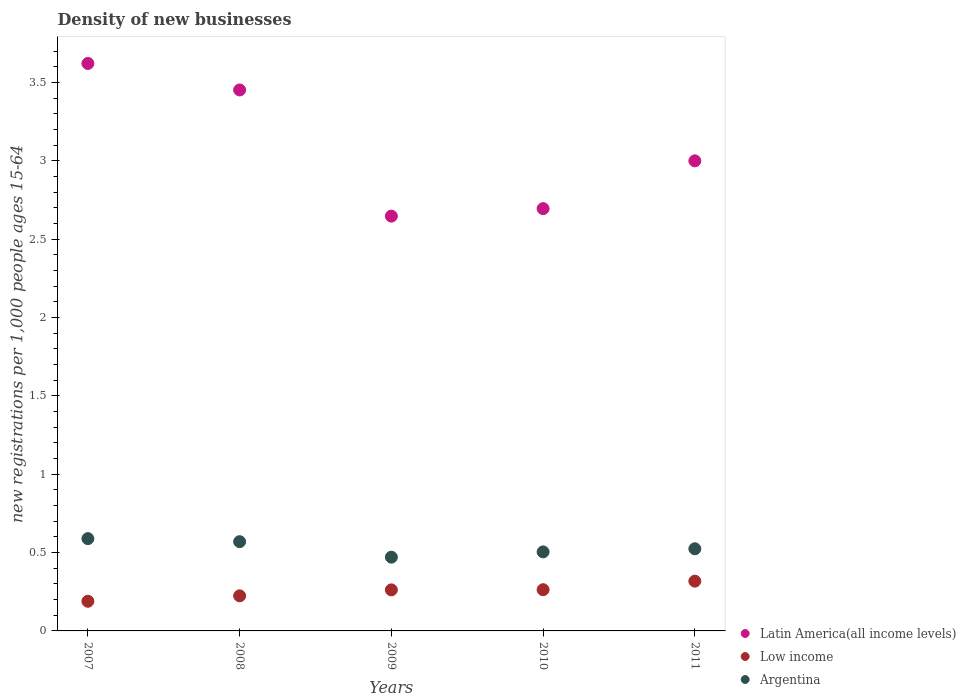Is the number of dotlines equal to the number of legend labels?
Offer a very short reply. Yes. What is the number of new registrations in Low income in 2011?
Your response must be concise. 0.32. Across all years, what is the maximum number of new registrations in Low income?
Offer a terse response. 0.32. Across all years, what is the minimum number of new registrations in Argentina?
Provide a succinct answer. 0.47. In which year was the number of new registrations in Argentina minimum?
Provide a short and direct response. 2009. What is the total number of new registrations in Argentina in the graph?
Offer a terse response. 2.66. What is the difference between the number of new registrations in Low income in 2007 and that in 2010?
Your response must be concise. -0.07. What is the difference between the number of new registrations in Argentina in 2007 and the number of new registrations in Low income in 2009?
Your response must be concise. 0.33. What is the average number of new registrations in Argentina per year?
Offer a very short reply. 0.53. In the year 2008, what is the difference between the number of new registrations in Low income and number of new registrations in Latin America(all income levels)?
Your answer should be very brief. -3.23. What is the ratio of the number of new registrations in Argentina in 2007 to that in 2010?
Your answer should be very brief. 1.17. What is the difference between the highest and the second highest number of new registrations in Argentina?
Your response must be concise. 0.02. What is the difference between the highest and the lowest number of new registrations in Latin America(all income levels)?
Your answer should be compact. 0.97. Does the number of new registrations in Low income monotonically increase over the years?
Provide a succinct answer. Yes. Is the number of new registrations in Low income strictly less than the number of new registrations in Argentina over the years?
Give a very brief answer. Yes. How many dotlines are there?
Make the answer very short. 3. How many years are there in the graph?
Offer a very short reply. 5. Does the graph contain grids?
Offer a very short reply. No. What is the title of the graph?
Give a very brief answer. Density of new businesses. What is the label or title of the Y-axis?
Provide a succinct answer. New registrations per 1,0 people ages 15-64. What is the new registrations per 1,000 people ages 15-64 of Latin America(all income levels) in 2007?
Give a very brief answer. 3.62. What is the new registrations per 1,000 people ages 15-64 of Low income in 2007?
Provide a succinct answer. 0.19. What is the new registrations per 1,000 people ages 15-64 of Argentina in 2007?
Provide a short and direct response. 0.59. What is the new registrations per 1,000 people ages 15-64 in Latin America(all income levels) in 2008?
Give a very brief answer. 3.45. What is the new registrations per 1,000 people ages 15-64 in Low income in 2008?
Offer a terse response. 0.22. What is the new registrations per 1,000 people ages 15-64 in Argentina in 2008?
Provide a succinct answer. 0.57. What is the new registrations per 1,000 people ages 15-64 of Latin America(all income levels) in 2009?
Your response must be concise. 2.65. What is the new registrations per 1,000 people ages 15-64 of Low income in 2009?
Your response must be concise. 0.26. What is the new registrations per 1,000 people ages 15-64 of Argentina in 2009?
Ensure brevity in your answer.  0.47. What is the new registrations per 1,000 people ages 15-64 of Latin America(all income levels) in 2010?
Keep it short and to the point. 2.69. What is the new registrations per 1,000 people ages 15-64 in Low income in 2010?
Offer a very short reply. 0.26. What is the new registrations per 1,000 people ages 15-64 of Argentina in 2010?
Ensure brevity in your answer.  0.5. What is the new registrations per 1,000 people ages 15-64 in Latin America(all income levels) in 2011?
Give a very brief answer. 3. What is the new registrations per 1,000 people ages 15-64 in Low income in 2011?
Your response must be concise. 0.32. What is the new registrations per 1,000 people ages 15-64 of Argentina in 2011?
Your answer should be compact. 0.52. Across all years, what is the maximum new registrations per 1,000 people ages 15-64 of Latin America(all income levels)?
Give a very brief answer. 3.62. Across all years, what is the maximum new registrations per 1,000 people ages 15-64 of Low income?
Your answer should be very brief. 0.32. Across all years, what is the maximum new registrations per 1,000 people ages 15-64 of Argentina?
Ensure brevity in your answer.  0.59. Across all years, what is the minimum new registrations per 1,000 people ages 15-64 of Latin America(all income levels)?
Your answer should be compact. 2.65. Across all years, what is the minimum new registrations per 1,000 people ages 15-64 in Low income?
Your answer should be very brief. 0.19. Across all years, what is the minimum new registrations per 1,000 people ages 15-64 in Argentina?
Provide a short and direct response. 0.47. What is the total new registrations per 1,000 people ages 15-64 of Latin America(all income levels) in the graph?
Offer a terse response. 15.41. What is the total new registrations per 1,000 people ages 15-64 of Low income in the graph?
Provide a succinct answer. 1.26. What is the total new registrations per 1,000 people ages 15-64 of Argentina in the graph?
Keep it short and to the point. 2.66. What is the difference between the new registrations per 1,000 people ages 15-64 of Latin America(all income levels) in 2007 and that in 2008?
Offer a terse response. 0.17. What is the difference between the new registrations per 1,000 people ages 15-64 of Low income in 2007 and that in 2008?
Your response must be concise. -0.03. What is the difference between the new registrations per 1,000 people ages 15-64 of Argentina in 2007 and that in 2008?
Your answer should be very brief. 0.02. What is the difference between the new registrations per 1,000 people ages 15-64 of Latin America(all income levels) in 2007 and that in 2009?
Offer a terse response. 0.97. What is the difference between the new registrations per 1,000 people ages 15-64 in Low income in 2007 and that in 2009?
Ensure brevity in your answer.  -0.07. What is the difference between the new registrations per 1,000 people ages 15-64 in Argentina in 2007 and that in 2009?
Give a very brief answer. 0.12. What is the difference between the new registrations per 1,000 people ages 15-64 of Latin America(all income levels) in 2007 and that in 2010?
Make the answer very short. 0.93. What is the difference between the new registrations per 1,000 people ages 15-64 in Low income in 2007 and that in 2010?
Offer a very short reply. -0.07. What is the difference between the new registrations per 1,000 people ages 15-64 of Argentina in 2007 and that in 2010?
Offer a terse response. 0.08. What is the difference between the new registrations per 1,000 people ages 15-64 in Latin America(all income levels) in 2007 and that in 2011?
Provide a succinct answer. 0.62. What is the difference between the new registrations per 1,000 people ages 15-64 in Low income in 2007 and that in 2011?
Your answer should be compact. -0.13. What is the difference between the new registrations per 1,000 people ages 15-64 in Argentina in 2007 and that in 2011?
Give a very brief answer. 0.06. What is the difference between the new registrations per 1,000 people ages 15-64 in Latin America(all income levels) in 2008 and that in 2009?
Your answer should be compact. 0.81. What is the difference between the new registrations per 1,000 people ages 15-64 of Low income in 2008 and that in 2009?
Ensure brevity in your answer.  -0.04. What is the difference between the new registrations per 1,000 people ages 15-64 in Argentina in 2008 and that in 2009?
Your answer should be compact. 0.1. What is the difference between the new registrations per 1,000 people ages 15-64 in Latin America(all income levels) in 2008 and that in 2010?
Your answer should be compact. 0.76. What is the difference between the new registrations per 1,000 people ages 15-64 in Low income in 2008 and that in 2010?
Keep it short and to the point. -0.04. What is the difference between the new registrations per 1,000 people ages 15-64 of Argentina in 2008 and that in 2010?
Provide a short and direct response. 0.07. What is the difference between the new registrations per 1,000 people ages 15-64 in Latin America(all income levels) in 2008 and that in 2011?
Give a very brief answer. 0.45. What is the difference between the new registrations per 1,000 people ages 15-64 of Low income in 2008 and that in 2011?
Give a very brief answer. -0.09. What is the difference between the new registrations per 1,000 people ages 15-64 in Argentina in 2008 and that in 2011?
Provide a succinct answer. 0.05. What is the difference between the new registrations per 1,000 people ages 15-64 of Latin America(all income levels) in 2009 and that in 2010?
Your answer should be very brief. -0.05. What is the difference between the new registrations per 1,000 people ages 15-64 of Low income in 2009 and that in 2010?
Your answer should be very brief. -0. What is the difference between the new registrations per 1,000 people ages 15-64 of Argentina in 2009 and that in 2010?
Ensure brevity in your answer.  -0.03. What is the difference between the new registrations per 1,000 people ages 15-64 in Latin America(all income levels) in 2009 and that in 2011?
Your response must be concise. -0.35. What is the difference between the new registrations per 1,000 people ages 15-64 of Low income in 2009 and that in 2011?
Make the answer very short. -0.06. What is the difference between the new registrations per 1,000 people ages 15-64 in Argentina in 2009 and that in 2011?
Provide a succinct answer. -0.05. What is the difference between the new registrations per 1,000 people ages 15-64 of Latin America(all income levels) in 2010 and that in 2011?
Keep it short and to the point. -0.3. What is the difference between the new registrations per 1,000 people ages 15-64 of Low income in 2010 and that in 2011?
Offer a terse response. -0.05. What is the difference between the new registrations per 1,000 people ages 15-64 in Argentina in 2010 and that in 2011?
Your answer should be very brief. -0.02. What is the difference between the new registrations per 1,000 people ages 15-64 in Latin America(all income levels) in 2007 and the new registrations per 1,000 people ages 15-64 in Low income in 2008?
Give a very brief answer. 3.4. What is the difference between the new registrations per 1,000 people ages 15-64 in Latin America(all income levels) in 2007 and the new registrations per 1,000 people ages 15-64 in Argentina in 2008?
Ensure brevity in your answer.  3.05. What is the difference between the new registrations per 1,000 people ages 15-64 of Low income in 2007 and the new registrations per 1,000 people ages 15-64 of Argentina in 2008?
Make the answer very short. -0.38. What is the difference between the new registrations per 1,000 people ages 15-64 of Latin America(all income levels) in 2007 and the new registrations per 1,000 people ages 15-64 of Low income in 2009?
Offer a very short reply. 3.36. What is the difference between the new registrations per 1,000 people ages 15-64 of Latin America(all income levels) in 2007 and the new registrations per 1,000 people ages 15-64 of Argentina in 2009?
Offer a terse response. 3.15. What is the difference between the new registrations per 1,000 people ages 15-64 in Low income in 2007 and the new registrations per 1,000 people ages 15-64 in Argentina in 2009?
Your answer should be compact. -0.28. What is the difference between the new registrations per 1,000 people ages 15-64 of Latin America(all income levels) in 2007 and the new registrations per 1,000 people ages 15-64 of Low income in 2010?
Your response must be concise. 3.36. What is the difference between the new registrations per 1,000 people ages 15-64 of Latin America(all income levels) in 2007 and the new registrations per 1,000 people ages 15-64 of Argentina in 2010?
Offer a terse response. 3.12. What is the difference between the new registrations per 1,000 people ages 15-64 in Low income in 2007 and the new registrations per 1,000 people ages 15-64 in Argentina in 2010?
Keep it short and to the point. -0.32. What is the difference between the new registrations per 1,000 people ages 15-64 of Latin America(all income levels) in 2007 and the new registrations per 1,000 people ages 15-64 of Low income in 2011?
Ensure brevity in your answer.  3.3. What is the difference between the new registrations per 1,000 people ages 15-64 of Latin America(all income levels) in 2007 and the new registrations per 1,000 people ages 15-64 of Argentina in 2011?
Offer a terse response. 3.1. What is the difference between the new registrations per 1,000 people ages 15-64 in Low income in 2007 and the new registrations per 1,000 people ages 15-64 in Argentina in 2011?
Give a very brief answer. -0.34. What is the difference between the new registrations per 1,000 people ages 15-64 in Latin America(all income levels) in 2008 and the new registrations per 1,000 people ages 15-64 in Low income in 2009?
Provide a short and direct response. 3.19. What is the difference between the new registrations per 1,000 people ages 15-64 of Latin America(all income levels) in 2008 and the new registrations per 1,000 people ages 15-64 of Argentina in 2009?
Your response must be concise. 2.98. What is the difference between the new registrations per 1,000 people ages 15-64 in Low income in 2008 and the new registrations per 1,000 people ages 15-64 in Argentina in 2009?
Keep it short and to the point. -0.25. What is the difference between the new registrations per 1,000 people ages 15-64 in Latin America(all income levels) in 2008 and the new registrations per 1,000 people ages 15-64 in Low income in 2010?
Keep it short and to the point. 3.19. What is the difference between the new registrations per 1,000 people ages 15-64 in Latin America(all income levels) in 2008 and the new registrations per 1,000 people ages 15-64 in Argentina in 2010?
Provide a short and direct response. 2.95. What is the difference between the new registrations per 1,000 people ages 15-64 of Low income in 2008 and the new registrations per 1,000 people ages 15-64 of Argentina in 2010?
Your response must be concise. -0.28. What is the difference between the new registrations per 1,000 people ages 15-64 of Latin America(all income levels) in 2008 and the new registrations per 1,000 people ages 15-64 of Low income in 2011?
Your response must be concise. 3.13. What is the difference between the new registrations per 1,000 people ages 15-64 of Latin America(all income levels) in 2008 and the new registrations per 1,000 people ages 15-64 of Argentina in 2011?
Your answer should be very brief. 2.93. What is the difference between the new registrations per 1,000 people ages 15-64 in Low income in 2008 and the new registrations per 1,000 people ages 15-64 in Argentina in 2011?
Ensure brevity in your answer.  -0.3. What is the difference between the new registrations per 1,000 people ages 15-64 of Latin America(all income levels) in 2009 and the new registrations per 1,000 people ages 15-64 of Low income in 2010?
Provide a short and direct response. 2.38. What is the difference between the new registrations per 1,000 people ages 15-64 in Latin America(all income levels) in 2009 and the new registrations per 1,000 people ages 15-64 in Argentina in 2010?
Provide a short and direct response. 2.14. What is the difference between the new registrations per 1,000 people ages 15-64 in Low income in 2009 and the new registrations per 1,000 people ages 15-64 in Argentina in 2010?
Offer a terse response. -0.24. What is the difference between the new registrations per 1,000 people ages 15-64 in Latin America(all income levels) in 2009 and the new registrations per 1,000 people ages 15-64 in Low income in 2011?
Provide a short and direct response. 2.33. What is the difference between the new registrations per 1,000 people ages 15-64 in Latin America(all income levels) in 2009 and the new registrations per 1,000 people ages 15-64 in Argentina in 2011?
Your answer should be compact. 2.12. What is the difference between the new registrations per 1,000 people ages 15-64 in Low income in 2009 and the new registrations per 1,000 people ages 15-64 in Argentina in 2011?
Provide a short and direct response. -0.26. What is the difference between the new registrations per 1,000 people ages 15-64 of Latin America(all income levels) in 2010 and the new registrations per 1,000 people ages 15-64 of Low income in 2011?
Offer a terse response. 2.38. What is the difference between the new registrations per 1,000 people ages 15-64 of Latin America(all income levels) in 2010 and the new registrations per 1,000 people ages 15-64 of Argentina in 2011?
Provide a short and direct response. 2.17. What is the difference between the new registrations per 1,000 people ages 15-64 of Low income in 2010 and the new registrations per 1,000 people ages 15-64 of Argentina in 2011?
Your answer should be compact. -0.26. What is the average new registrations per 1,000 people ages 15-64 in Latin America(all income levels) per year?
Offer a very short reply. 3.08. What is the average new registrations per 1,000 people ages 15-64 in Low income per year?
Provide a succinct answer. 0.25. What is the average new registrations per 1,000 people ages 15-64 in Argentina per year?
Offer a terse response. 0.53. In the year 2007, what is the difference between the new registrations per 1,000 people ages 15-64 of Latin America(all income levels) and new registrations per 1,000 people ages 15-64 of Low income?
Ensure brevity in your answer.  3.43. In the year 2007, what is the difference between the new registrations per 1,000 people ages 15-64 in Latin America(all income levels) and new registrations per 1,000 people ages 15-64 in Argentina?
Your answer should be very brief. 3.03. In the year 2007, what is the difference between the new registrations per 1,000 people ages 15-64 of Low income and new registrations per 1,000 people ages 15-64 of Argentina?
Give a very brief answer. -0.4. In the year 2008, what is the difference between the new registrations per 1,000 people ages 15-64 of Latin America(all income levels) and new registrations per 1,000 people ages 15-64 of Low income?
Offer a very short reply. 3.23. In the year 2008, what is the difference between the new registrations per 1,000 people ages 15-64 in Latin America(all income levels) and new registrations per 1,000 people ages 15-64 in Argentina?
Provide a succinct answer. 2.88. In the year 2008, what is the difference between the new registrations per 1,000 people ages 15-64 of Low income and new registrations per 1,000 people ages 15-64 of Argentina?
Give a very brief answer. -0.35. In the year 2009, what is the difference between the new registrations per 1,000 people ages 15-64 of Latin America(all income levels) and new registrations per 1,000 people ages 15-64 of Low income?
Ensure brevity in your answer.  2.38. In the year 2009, what is the difference between the new registrations per 1,000 people ages 15-64 in Latin America(all income levels) and new registrations per 1,000 people ages 15-64 in Argentina?
Provide a succinct answer. 2.18. In the year 2009, what is the difference between the new registrations per 1,000 people ages 15-64 of Low income and new registrations per 1,000 people ages 15-64 of Argentina?
Provide a succinct answer. -0.21. In the year 2010, what is the difference between the new registrations per 1,000 people ages 15-64 of Latin America(all income levels) and new registrations per 1,000 people ages 15-64 of Low income?
Your answer should be compact. 2.43. In the year 2010, what is the difference between the new registrations per 1,000 people ages 15-64 of Latin America(all income levels) and new registrations per 1,000 people ages 15-64 of Argentina?
Your response must be concise. 2.19. In the year 2010, what is the difference between the new registrations per 1,000 people ages 15-64 in Low income and new registrations per 1,000 people ages 15-64 in Argentina?
Offer a very short reply. -0.24. In the year 2011, what is the difference between the new registrations per 1,000 people ages 15-64 in Latin America(all income levels) and new registrations per 1,000 people ages 15-64 in Low income?
Keep it short and to the point. 2.68. In the year 2011, what is the difference between the new registrations per 1,000 people ages 15-64 of Latin America(all income levels) and new registrations per 1,000 people ages 15-64 of Argentina?
Your response must be concise. 2.48. In the year 2011, what is the difference between the new registrations per 1,000 people ages 15-64 in Low income and new registrations per 1,000 people ages 15-64 in Argentina?
Give a very brief answer. -0.21. What is the ratio of the new registrations per 1,000 people ages 15-64 in Latin America(all income levels) in 2007 to that in 2008?
Give a very brief answer. 1.05. What is the ratio of the new registrations per 1,000 people ages 15-64 in Low income in 2007 to that in 2008?
Keep it short and to the point. 0.84. What is the ratio of the new registrations per 1,000 people ages 15-64 in Argentina in 2007 to that in 2008?
Keep it short and to the point. 1.03. What is the ratio of the new registrations per 1,000 people ages 15-64 in Latin America(all income levels) in 2007 to that in 2009?
Provide a short and direct response. 1.37. What is the ratio of the new registrations per 1,000 people ages 15-64 of Low income in 2007 to that in 2009?
Your answer should be compact. 0.72. What is the ratio of the new registrations per 1,000 people ages 15-64 of Argentina in 2007 to that in 2009?
Your answer should be compact. 1.25. What is the ratio of the new registrations per 1,000 people ages 15-64 in Latin America(all income levels) in 2007 to that in 2010?
Your answer should be very brief. 1.34. What is the ratio of the new registrations per 1,000 people ages 15-64 in Low income in 2007 to that in 2010?
Your answer should be very brief. 0.72. What is the ratio of the new registrations per 1,000 people ages 15-64 in Argentina in 2007 to that in 2010?
Provide a succinct answer. 1.17. What is the ratio of the new registrations per 1,000 people ages 15-64 of Latin America(all income levels) in 2007 to that in 2011?
Give a very brief answer. 1.21. What is the ratio of the new registrations per 1,000 people ages 15-64 in Low income in 2007 to that in 2011?
Give a very brief answer. 0.6. What is the ratio of the new registrations per 1,000 people ages 15-64 in Argentina in 2007 to that in 2011?
Your answer should be compact. 1.12. What is the ratio of the new registrations per 1,000 people ages 15-64 of Latin America(all income levels) in 2008 to that in 2009?
Keep it short and to the point. 1.3. What is the ratio of the new registrations per 1,000 people ages 15-64 in Low income in 2008 to that in 2009?
Give a very brief answer. 0.85. What is the ratio of the new registrations per 1,000 people ages 15-64 in Argentina in 2008 to that in 2009?
Your response must be concise. 1.21. What is the ratio of the new registrations per 1,000 people ages 15-64 of Latin America(all income levels) in 2008 to that in 2010?
Offer a very short reply. 1.28. What is the ratio of the new registrations per 1,000 people ages 15-64 of Low income in 2008 to that in 2010?
Your response must be concise. 0.85. What is the ratio of the new registrations per 1,000 people ages 15-64 in Argentina in 2008 to that in 2010?
Your answer should be very brief. 1.13. What is the ratio of the new registrations per 1,000 people ages 15-64 in Latin America(all income levels) in 2008 to that in 2011?
Offer a very short reply. 1.15. What is the ratio of the new registrations per 1,000 people ages 15-64 in Low income in 2008 to that in 2011?
Keep it short and to the point. 0.7. What is the ratio of the new registrations per 1,000 people ages 15-64 in Argentina in 2008 to that in 2011?
Ensure brevity in your answer.  1.09. What is the ratio of the new registrations per 1,000 people ages 15-64 in Latin America(all income levels) in 2009 to that in 2010?
Keep it short and to the point. 0.98. What is the ratio of the new registrations per 1,000 people ages 15-64 of Argentina in 2009 to that in 2010?
Give a very brief answer. 0.93. What is the ratio of the new registrations per 1,000 people ages 15-64 of Latin America(all income levels) in 2009 to that in 2011?
Your response must be concise. 0.88. What is the ratio of the new registrations per 1,000 people ages 15-64 of Low income in 2009 to that in 2011?
Keep it short and to the point. 0.82. What is the ratio of the new registrations per 1,000 people ages 15-64 of Argentina in 2009 to that in 2011?
Your answer should be very brief. 0.9. What is the ratio of the new registrations per 1,000 people ages 15-64 in Latin America(all income levels) in 2010 to that in 2011?
Provide a short and direct response. 0.9. What is the ratio of the new registrations per 1,000 people ages 15-64 of Low income in 2010 to that in 2011?
Your response must be concise. 0.83. What is the ratio of the new registrations per 1,000 people ages 15-64 of Argentina in 2010 to that in 2011?
Keep it short and to the point. 0.96. What is the difference between the highest and the second highest new registrations per 1,000 people ages 15-64 in Latin America(all income levels)?
Offer a terse response. 0.17. What is the difference between the highest and the second highest new registrations per 1,000 people ages 15-64 in Low income?
Your answer should be compact. 0.05. What is the difference between the highest and the second highest new registrations per 1,000 people ages 15-64 of Argentina?
Offer a terse response. 0.02. What is the difference between the highest and the lowest new registrations per 1,000 people ages 15-64 of Low income?
Provide a succinct answer. 0.13. What is the difference between the highest and the lowest new registrations per 1,000 people ages 15-64 of Argentina?
Your answer should be compact. 0.12. 